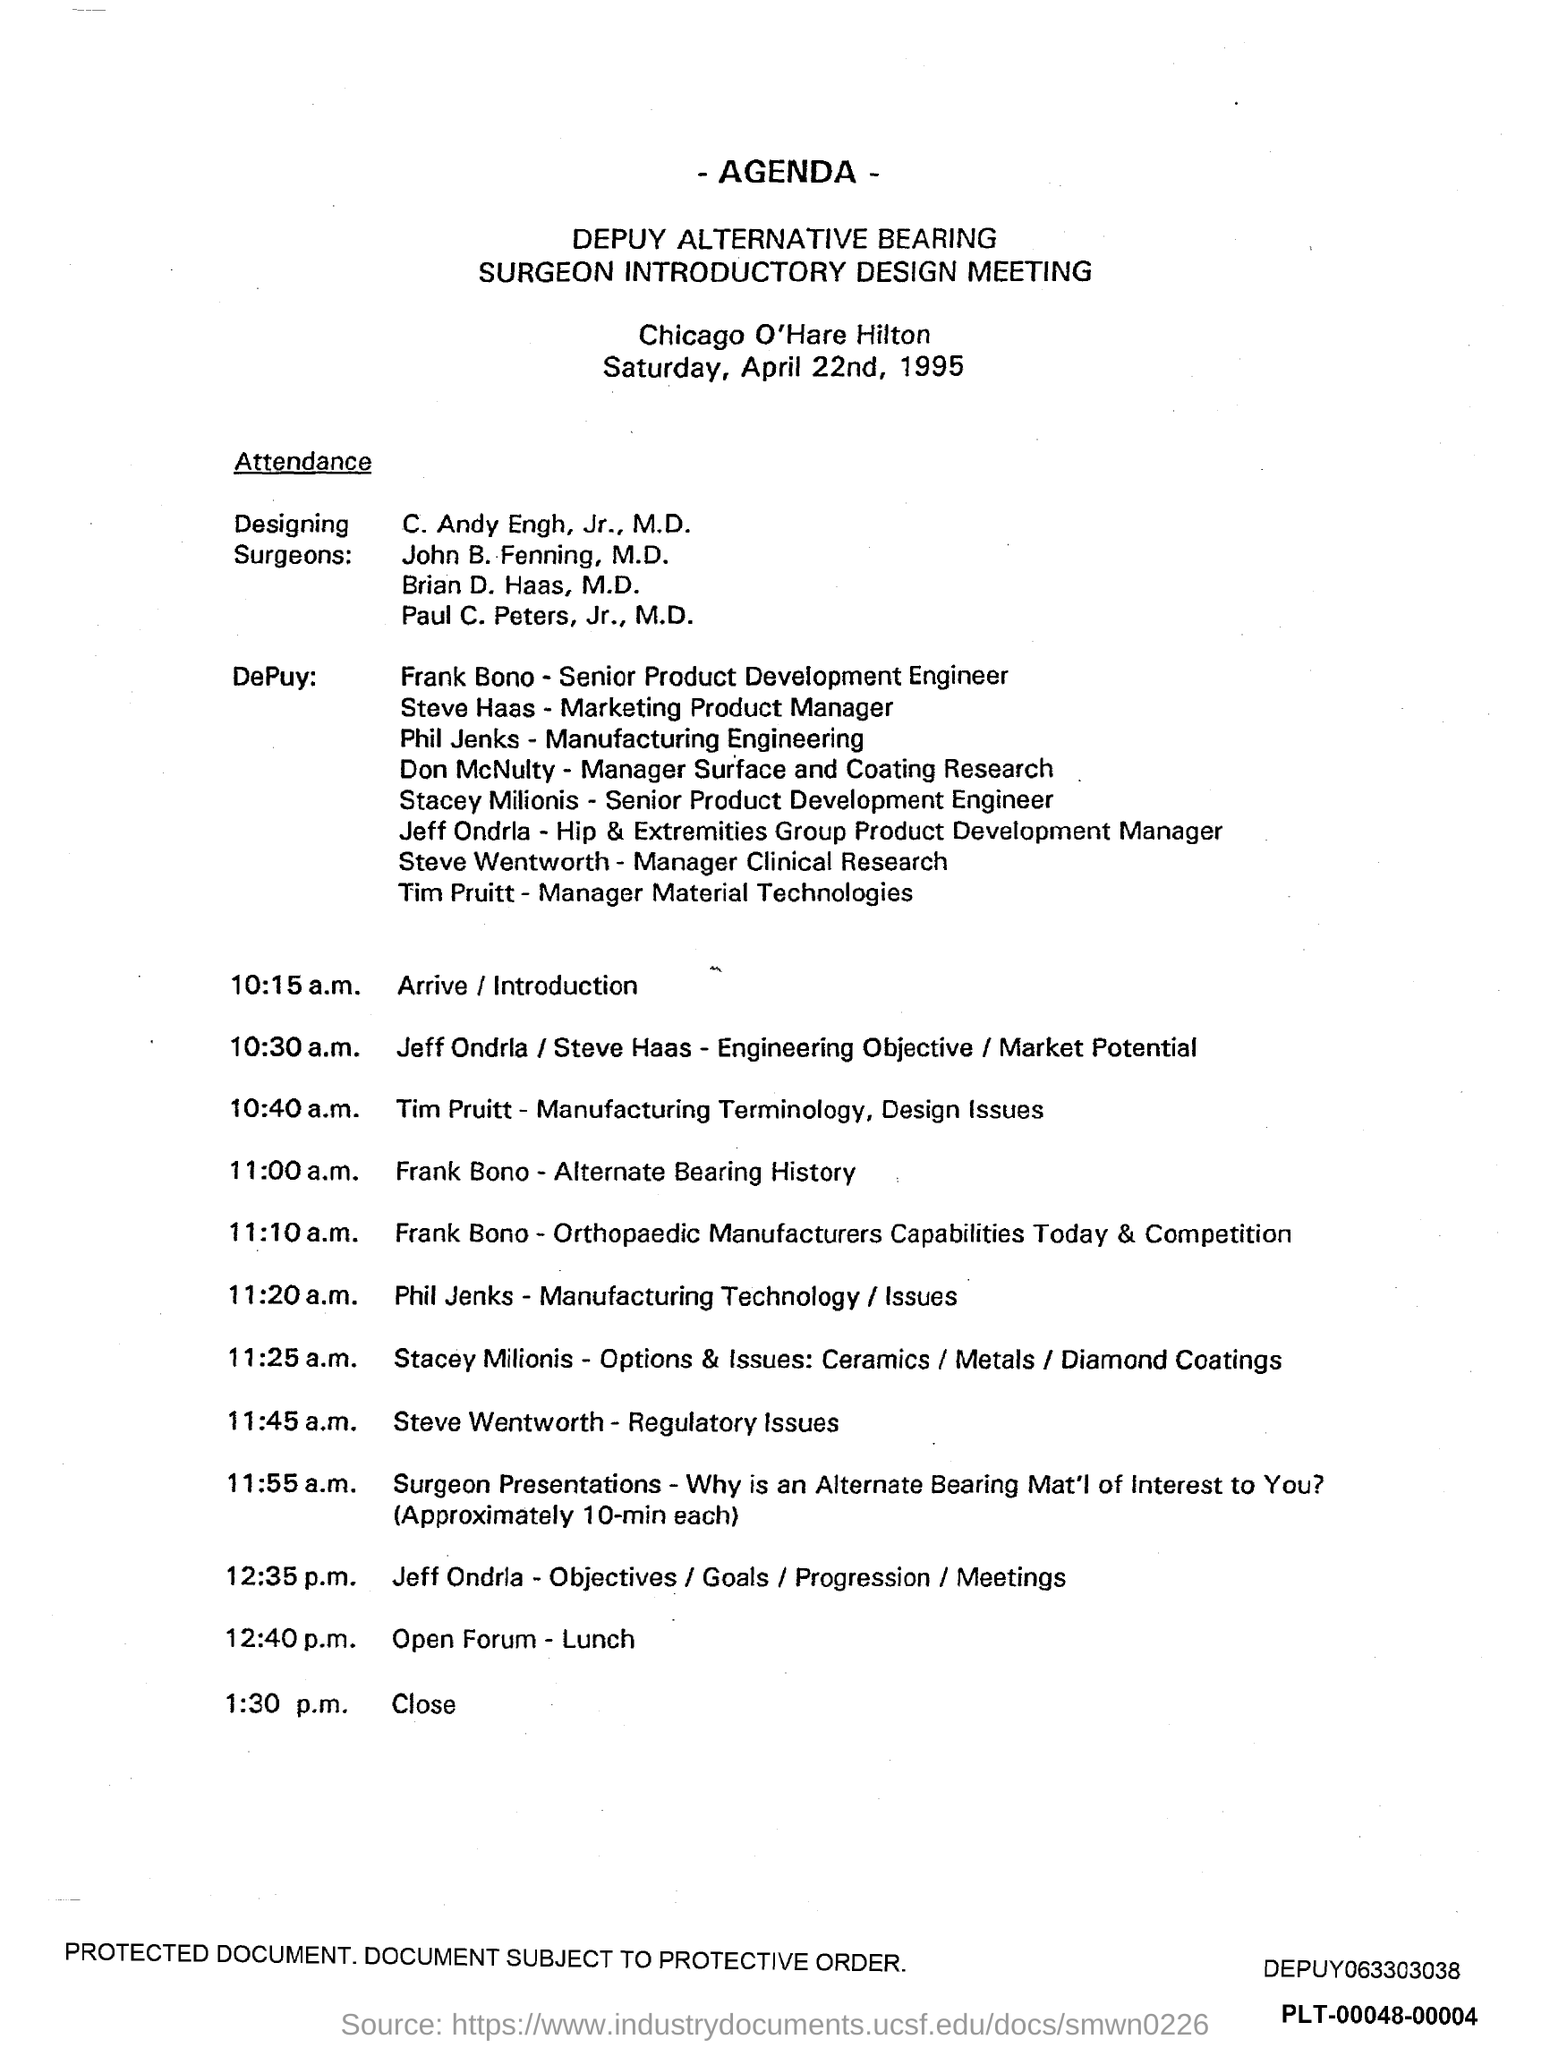what is the time scheduled for Close ?
 1:30 p.m 